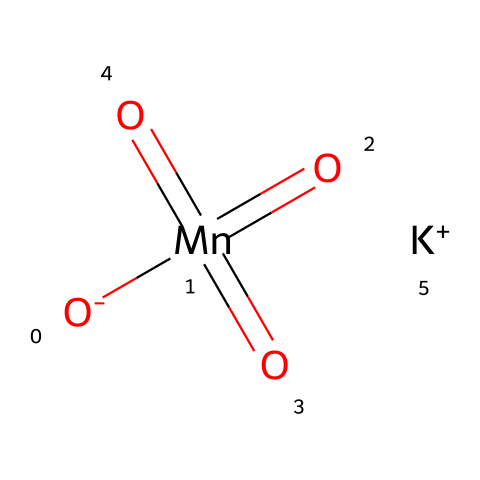What is the central atom in potassium permanganate? The central atom is manganese, which is indicated by the 'Mn' in the SMILES representation. It is the atom surrounded by oxygen atoms in the structure.
Answer: manganese How many oxygen atoms are present in potassium permanganate? The SMILES representation indicates four oxygen atoms are present, as seen from the four '[O]' portions in the notation.
Answer: four What is the charge of the potassium ion in this compound? The SMILES shows '[K+]', which denotes that the potassium ion has a positive charge of +1.
Answer: +1 What type of chemical is potassium permanganate categorized as? With its strong oxidative capability, potassium permanganate is classified as an oxidizer, as indicated by its high oxidation state of manganese and multiple oxygen connections.
Answer: oxidizer What is the oxidation state of manganese in this compound? In this case, manganese is shown as 'Mn' with four oxygen atoms bonded as oxo groups, which typically implies an oxidation state of +7 for manganese.
Answer: +7 How does potassium permanganate act as an oxidizer in water treatment? Potassium permanganate's structure allows it to readily accept electrons during chemical reactions, effectively oxidizing contaminants in water, thereby treating it.
Answer: accepts electrons 